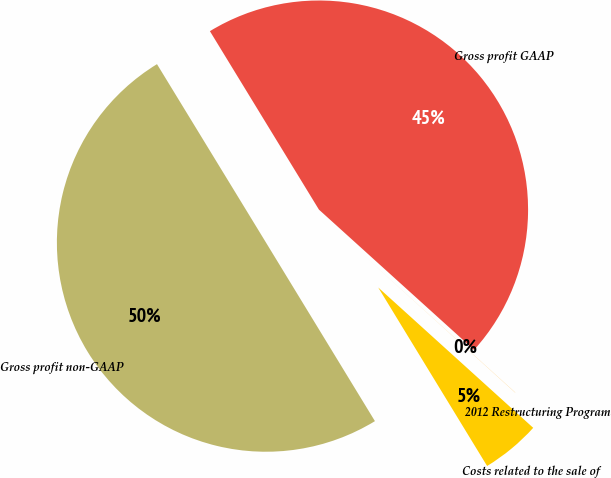Convert chart. <chart><loc_0><loc_0><loc_500><loc_500><pie_chart><fcel>Gross profit GAAP<fcel>2012 Restructuring Program<fcel>Costs related to the sale of<fcel>Gross profit non-GAAP<nl><fcel>45.43%<fcel>0.01%<fcel>4.57%<fcel>49.99%<nl></chart> 